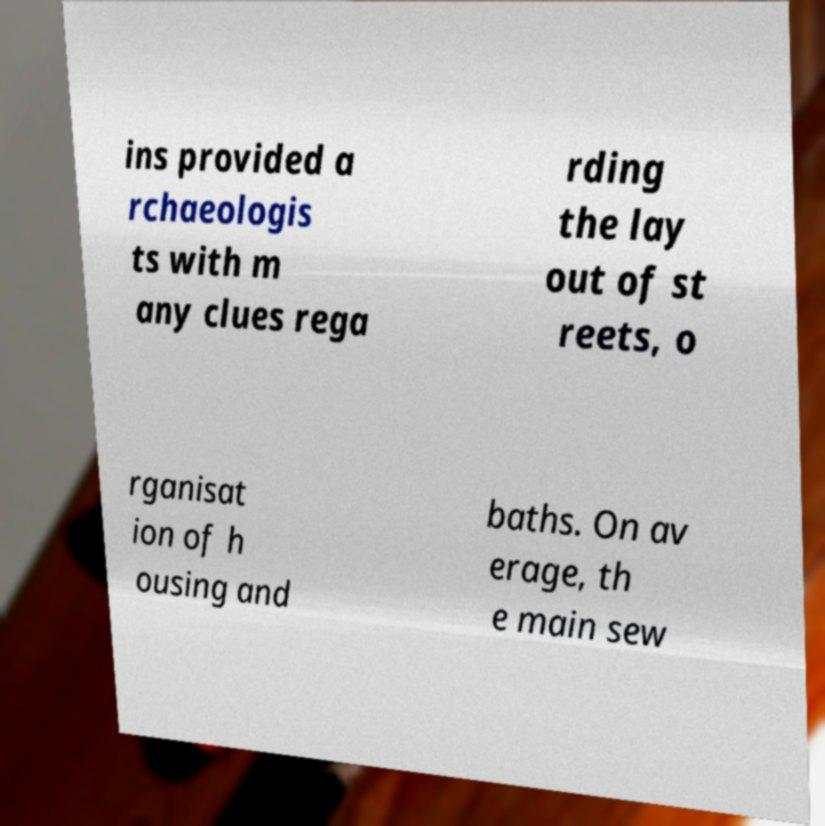For documentation purposes, I need the text within this image transcribed. Could you provide that? ins provided a rchaeologis ts with m any clues rega rding the lay out of st reets, o rganisat ion of h ousing and baths. On av erage, th e main sew 